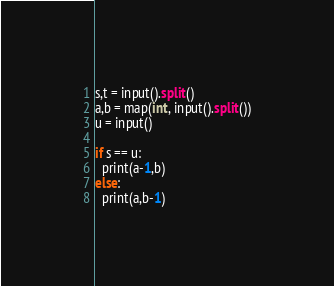Convert code to text. <code><loc_0><loc_0><loc_500><loc_500><_Java_>s,t = input().split()
a,b = map(int, input().split())
u = input()

if s == u:
  print(a-1,b)
else:
  print(a,b-1)</code> 